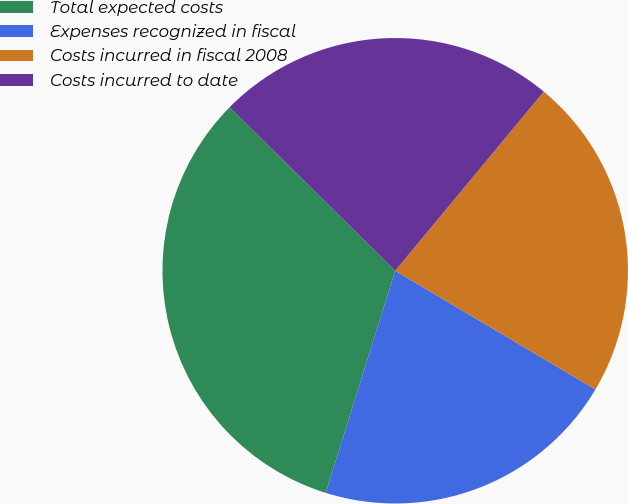Convert chart. <chart><loc_0><loc_0><loc_500><loc_500><pie_chart><fcel>Total expected costs<fcel>Expenses recognized in fiscal<fcel>Costs incurred in fiscal 2008<fcel>Costs incurred to date<nl><fcel>32.57%<fcel>21.31%<fcel>22.5%<fcel>23.62%<nl></chart> 